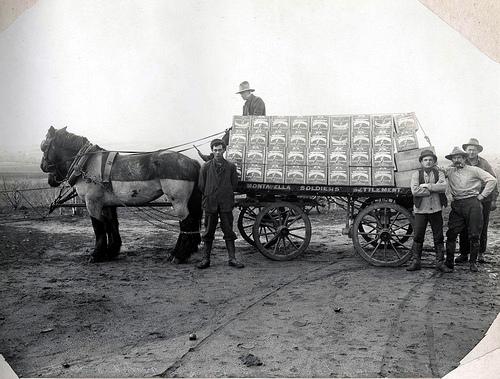Is this taken in modern times?
Keep it brief. No. Is this a zoo?
Be succinct. No. Are the roads paved?
Keep it brief. No. Are there any boxes on the cart?
Concise answer only. Yes. 